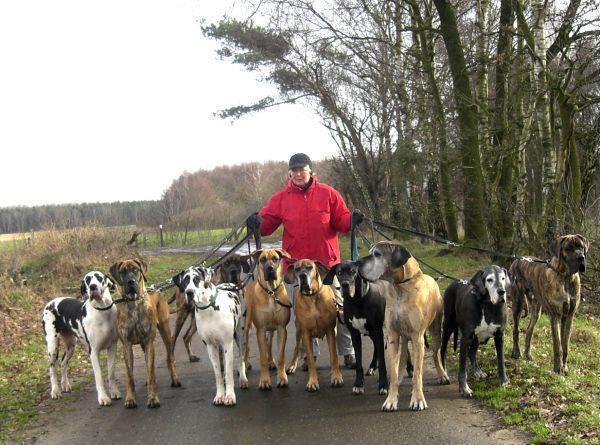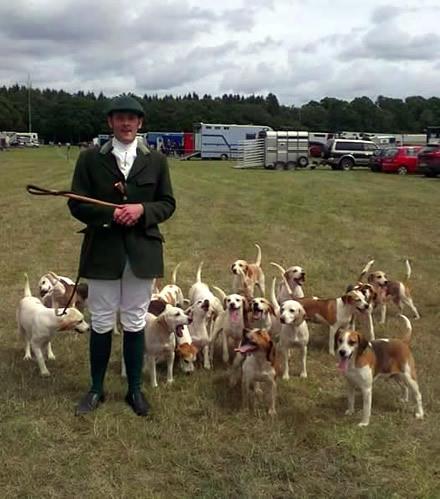The first image is the image on the left, the second image is the image on the right. Analyze the images presented: Is the assertion "Right image shows at least one man in white breeches with a pack of hounds." valid? Answer yes or no. Yes. The first image is the image on the left, the second image is the image on the right. Given the left and right images, does the statement "There is a single vehicle shown in one of the images." hold true? Answer yes or no. No. 